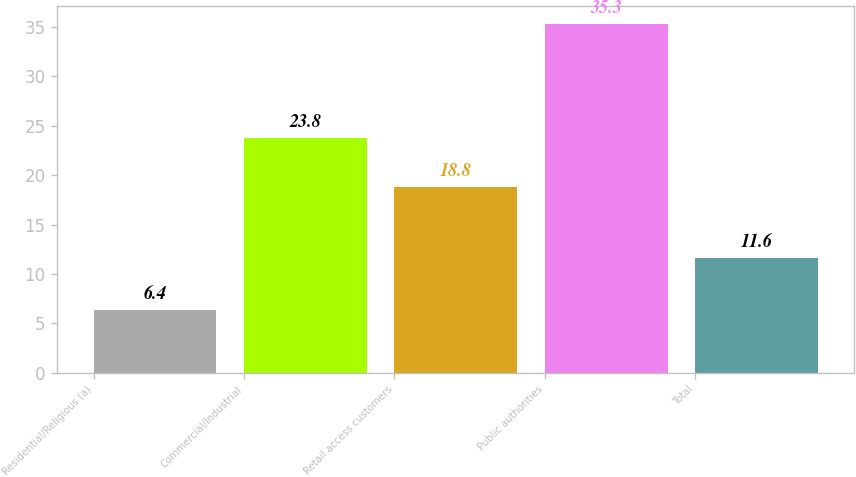Convert chart to OTSL. <chart><loc_0><loc_0><loc_500><loc_500><bar_chart><fcel>Residential/Religious (a)<fcel>Commercial/Industrial<fcel>Retail access customers<fcel>Public authorities<fcel>Total<nl><fcel>6.4<fcel>23.8<fcel>18.8<fcel>35.3<fcel>11.6<nl></chart> 